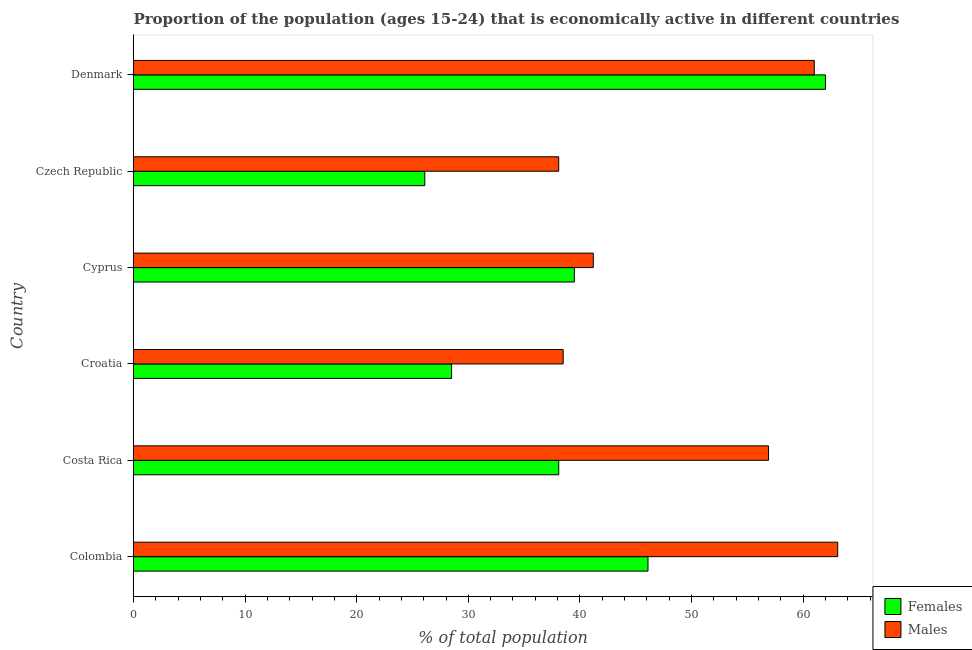How many different coloured bars are there?
Your answer should be very brief. 2. How many groups of bars are there?
Make the answer very short. 6. Are the number of bars on each tick of the Y-axis equal?
Your answer should be compact. Yes. How many bars are there on the 2nd tick from the top?
Give a very brief answer. 2. What is the label of the 4th group of bars from the top?
Ensure brevity in your answer.  Croatia. In how many cases, is the number of bars for a given country not equal to the number of legend labels?
Your response must be concise. 0. What is the percentage of economically active male population in Denmark?
Your response must be concise. 61. Across all countries, what is the maximum percentage of economically active male population?
Offer a terse response. 63.1. Across all countries, what is the minimum percentage of economically active male population?
Ensure brevity in your answer.  38.1. In which country was the percentage of economically active female population maximum?
Offer a very short reply. Denmark. In which country was the percentage of economically active female population minimum?
Provide a short and direct response. Czech Republic. What is the total percentage of economically active male population in the graph?
Your response must be concise. 298.8. What is the difference between the percentage of economically active male population in Costa Rica and the percentage of economically active female population in Croatia?
Give a very brief answer. 28.4. What is the average percentage of economically active male population per country?
Keep it short and to the point. 49.8. What is the difference between the percentage of economically active female population and percentage of economically active male population in Croatia?
Give a very brief answer. -10. What is the ratio of the percentage of economically active female population in Costa Rica to that in Czech Republic?
Ensure brevity in your answer.  1.46. Is the percentage of economically active female population in Colombia less than that in Czech Republic?
Make the answer very short. No. Is the difference between the percentage of economically active male population in Colombia and Cyprus greater than the difference between the percentage of economically active female population in Colombia and Cyprus?
Provide a succinct answer. Yes. What is the difference between the highest and the lowest percentage of economically active female population?
Provide a short and direct response. 35.9. In how many countries, is the percentage of economically active female population greater than the average percentage of economically active female population taken over all countries?
Offer a terse response. 2. Is the sum of the percentage of economically active female population in Costa Rica and Denmark greater than the maximum percentage of economically active male population across all countries?
Your answer should be very brief. Yes. What does the 2nd bar from the top in Czech Republic represents?
Ensure brevity in your answer.  Females. What does the 1st bar from the bottom in Colombia represents?
Your response must be concise. Females. Are all the bars in the graph horizontal?
Your response must be concise. Yes. What is the difference between two consecutive major ticks on the X-axis?
Your response must be concise. 10. Are the values on the major ticks of X-axis written in scientific E-notation?
Give a very brief answer. No. Does the graph contain any zero values?
Offer a terse response. No. Does the graph contain grids?
Make the answer very short. No. Where does the legend appear in the graph?
Offer a very short reply. Bottom right. How many legend labels are there?
Your answer should be compact. 2. What is the title of the graph?
Provide a short and direct response. Proportion of the population (ages 15-24) that is economically active in different countries. Does "Male labor force" appear as one of the legend labels in the graph?
Provide a succinct answer. No. What is the label or title of the X-axis?
Keep it short and to the point. % of total population. What is the label or title of the Y-axis?
Offer a very short reply. Country. What is the % of total population in Females in Colombia?
Offer a very short reply. 46.1. What is the % of total population of Males in Colombia?
Keep it short and to the point. 63.1. What is the % of total population of Females in Costa Rica?
Offer a terse response. 38.1. What is the % of total population in Males in Costa Rica?
Your response must be concise. 56.9. What is the % of total population of Females in Croatia?
Provide a succinct answer. 28.5. What is the % of total population in Males in Croatia?
Offer a very short reply. 38.5. What is the % of total population in Females in Cyprus?
Your answer should be compact. 39.5. What is the % of total population in Males in Cyprus?
Your answer should be very brief. 41.2. What is the % of total population in Females in Czech Republic?
Ensure brevity in your answer.  26.1. What is the % of total population of Males in Czech Republic?
Ensure brevity in your answer.  38.1. What is the % of total population of Females in Denmark?
Provide a succinct answer. 62. Across all countries, what is the maximum % of total population of Females?
Offer a terse response. 62. Across all countries, what is the maximum % of total population in Males?
Your answer should be very brief. 63.1. Across all countries, what is the minimum % of total population in Females?
Your response must be concise. 26.1. Across all countries, what is the minimum % of total population of Males?
Provide a succinct answer. 38.1. What is the total % of total population of Females in the graph?
Keep it short and to the point. 240.3. What is the total % of total population in Males in the graph?
Keep it short and to the point. 298.8. What is the difference between the % of total population in Females in Colombia and that in Costa Rica?
Provide a succinct answer. 8. What is the difference between the % of total population in Females in Colombia and that in Croatia?
Keep it short and to the point. 17.6. What is the difference between the % of total population in Males in Colombia and that in Croatia?
Ensure brevity in your answer.  24.6. What is the difference between the % of total population in Females in Colombia and that in Cyprus?
Your response must be concise. 6.6. What is the difference between the % of total population of Males in Colombia and that in Cyprus?
Ensure brevity in your answer.  21.9. What is the difference between the % of total population of Females in Colombia and that in Czech Republic?
Offer a terse response. 20. What is the difference between the % of total population of Males in Colombia and that in Czech Republic?
Your answer should be compact. 25. What is the difference between the % of total population of Females in Colombia and that in Denmark?
Provide a short and direct response. -15.9. What is the difference between the % of total population of Males in Costa Rica and that in Cyprus?
Your answer should be very brief. 15.7. What is the difference between the % of total population in Males in Costa Rica and that in Czech Republic?
Provide a succinct answer. 18.8. What is the difference between the % of total population in Females in Costa Rica and that in Denmark?
Make the answer very short. -23.9. What is the difference between the % of total population in Males in Croatia and that in Cyprus?
Keep it short and to the point. -2.7. What is the difference between the % of total population in Males in Croatia and that in Czech Republic?
Keep it short and to the point. 0.4. What is the difference between the % of total population in Females in Croatia and that in Denmark?
Provide a short and direct response. -33.5. What is the difference between the % of total population of Males in Croatia and that in Denmark?
Your response must be concise. -22.5. What is the difference between the % of total population of Males in Cyprus and that in Czech Republic?
Your response must be concise. 3.1. What is the difference between the % of total population in Females in Cyprus and that in Denmark?
Your answer should be very brief. -22.5. What is the difference between the % of total population of Males in Cyprus and that in Denmark?
Give a very brief answer. -19.8. What is the difference between the % of total population of Females in Czech Republic and that in Denmark?
Your answer should be very brief. -35.9. What is the difference between the % of total population in Males in Czech Republic and that in Denmark?
Your answer should be very brief. -22.9. What is the difference between the % of total population of Females in Colombia and the % of total population of Males in Croatia?
Give a very brief answer. 7.6. What is the difference between the % of total population in Females in Colombia and the % of total population in Males in Denmark?
Your answer should be very brief. -14.9. What is the difference between the % of total population in Females in Costa Rica and the % of total population in Males in Denmark?
Ensure brevity in your answer.  -22.9. What is the difference between the % of total population of Females in Croatia and the % of total population of Males in Denmark?
Make the answer very short. -32.5. What is the difference between the % of total population in Females in Cyprus and the % of total population in Males in Denmark?
Offer a terse response. -21.5. What is the difference between the % of total population of Females in Czech Republic and the % of total population of Males in Denmark?
Keep it short and to the point. -34.9. What is the average % of total population in Females per country?
Your answer should be compact. 40.05. What is the average % of total population of Males per country?
Provide a short and direct response. 49.8. What is the difference between the % of total population of Females and % of total population of Males in Colombia?
Offer a terse response. -17. What is the difference between the % of total population of Females and % of total population of Males in Costa Rica?
Offer a terse response. -18.8. What is the difference between the % of total population in Females and % of total population in Males in Czech Republic?
Keep it short and to the point. -12. What is the difference between the % of total population of Females and % of total population of Males in Denmark?
Give a very brief answer. 1. What is the ratio of the % of total population in Females in Colombia to that in Costa Rica?
Keep it short and to the point. 1.21. What is the ratio of the % of total population in Males in Colombia to that in Costa Rica?
Offer a terse response. 1.11. What is the ratio of the % of total population in Females in Colombia to that in Croatia?
Give a very brief answer. 1.62. What is the ratio of the % of total population of Males in Colombia to that in Croatia?
Your answer should be very brief. 1.64. What is the ratio of the % of total population in Females in Colombia to that in Cyprus?
Your answer should be very brief. 1.17. What is the ratio of the % of total population of Males in Colombia to that in Cyprus?
Your answer should be compact. 1.53. What is the ratio of the % of total population in Females in Colombia to that in Czech Republic?
Make the answer very short. 1.77. What is the ratio of the % of total population of Males in Colombia to that in Czech Republic?
Offer a very short reply. 1.66. What is the ratio of the % of total population in Females in Colombia to that in Denmark?
Make the answer very short. 0.74. What is the ratio of the % of total population in Males in Colombia to that in Denmark?
Your response must be concise. 1.03. What is the ratio of the % of total population of Females in Costa Rica to that in Croatia?
Your response must be concise. 1.34. What is the ratio of the % of total population of Males in Costa Rica to that in Croatia?
Your response must be concise. 1.48. What is the ratio of the % of total population of Females in Costa Rica to that in Cyprus?
Provide a short and direct response. 0.96. What is the ratio of the % of total population of Males in Costa Rica to that in Cyprus?
Make the answer very short. 1.38. What is the ratio of the % of total population of Females in Costa Rica to that in Czech Republic?
Your response must be concise. 1.46. What is the ratio of the % of total population in Males in Costa Rica to that in Czech Republic?
Offer a terse response. 1.49. What is the ratio of the % of total population in Females in Costa Rica to that in Denmark?
Ensure brevity in your answer.  0.61. What is the ratio of the % of total population in Males in Costa Rica to that in Denmark?
Your answer should be very brief. 0.93. What is the ratio of the % of total population of Females in Croatia to that in Cyprus?
Offer a terse response. 0.72. What is the ratio of the % of total population in Males in Croatia to that in Cyprus?
Offer a terse response. 0.93. What is the ratio of the % of total population in Females in Croatia to that in Czech Republic?
Keep it short and to the point. 1.09. What is the ratio of the % of total population in Males in Croatia to that in Czech Republic?
Your answer should be very brief. 1.01. What is the ratio of the % of total population of Females in Croatia to that in Denmark?
Offer a very short reply. 0.46. What is the ratio of the % of total population of Males in Croatia to that in Denmark?
Give a very brief answer. 0.63. What is the ratio of the % of total population of Females in Cyprus to that in Czech Republic?
Provide a succinct answer. 1.51. What is the ratio of the % of total population of Males in Cyprus to that in Czech Republic?
Offer a very short reply. 1.08. What is the ratio of the % of total population of Females in Cyprus to that in Denmark?
Give a very brief answer. 0.64. What is the ratio of the % of total population in Males in Cyprus to that in Denmark?
Make the answer very short. 0.68. What is the ratio of the % of total population of Females in Czech Republic to that in Denmark?
Provide a succinct answer. 0.42. What is the ratio of the % of total population of Males in Czech Republic to that in Denmark?
Your answer should be compact. 0.62. What is the difference between the highest and the second highest % of total population in Females?
Give a very brief answer. 15.9. What is the difference between the highest and the lowest % of total population of Females?
Keep it short and to the point. 35.9. 